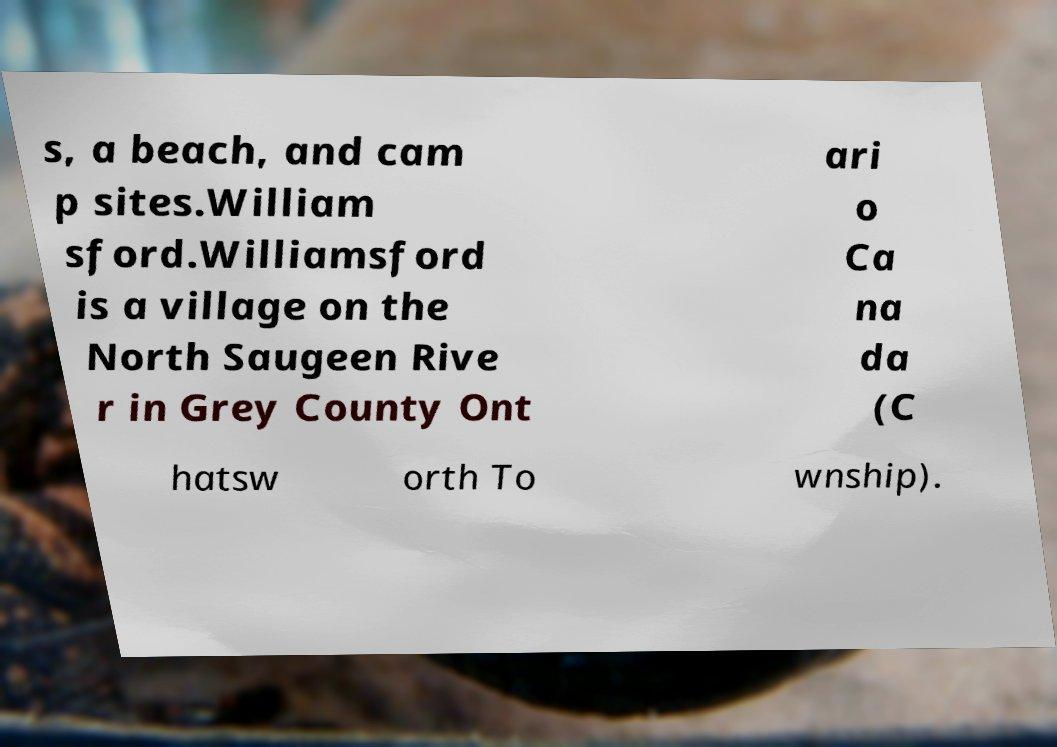Can you read and provide the text displayed in the image?This photo seems to have some interesting text. Can you extract and type it out for me? s, a beach, and cam p sites.William sford.Williamsford is a village on the North Saugeen Rive r in Grey County Ont ari o Ca na da (C hatsw orth To wnship). 